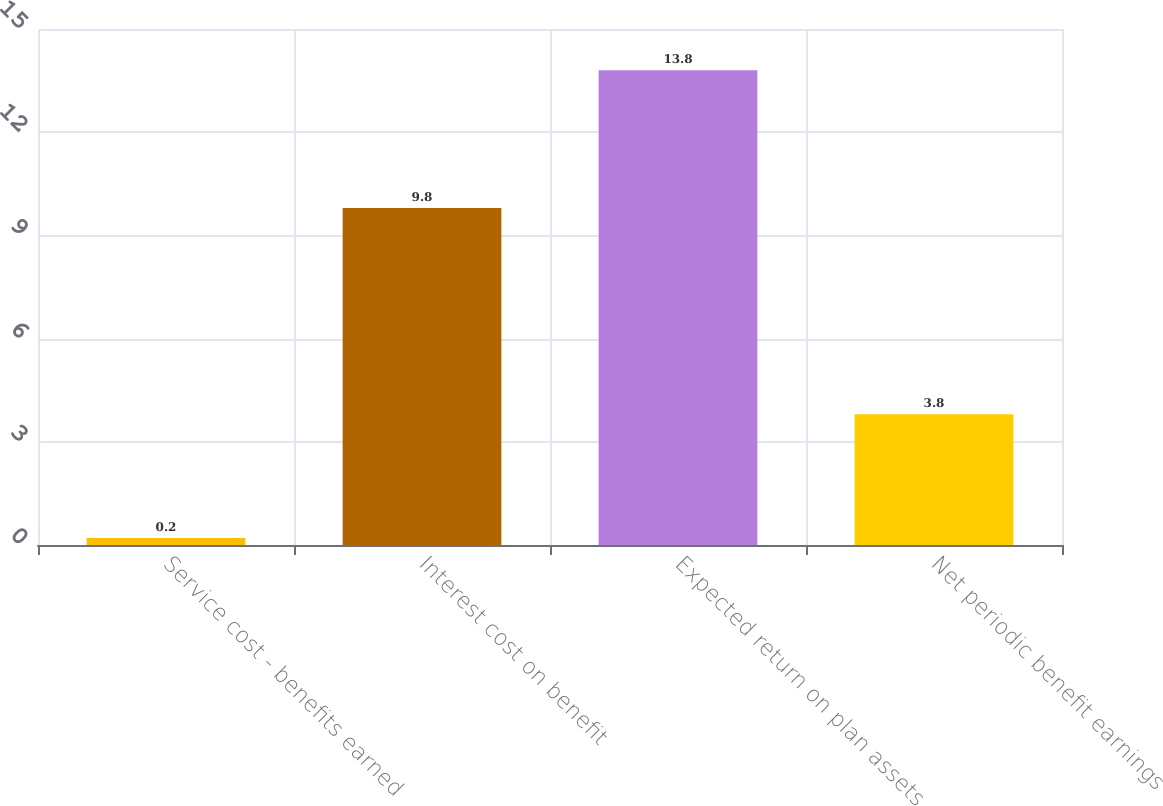Convert chart to OTSL. <chart><loc_0><loc_0><loc_500><loc_500><bar_chart><fcel>Service cost - benefits earned<fcel>Interest cost on benefit<fcel>Expected return on plan assets<fcel>Net periodic benefit earnings<nl><fcel>0.2<fcel>9.8<fcel>13.8<fcel>3.8<nl></chart> 